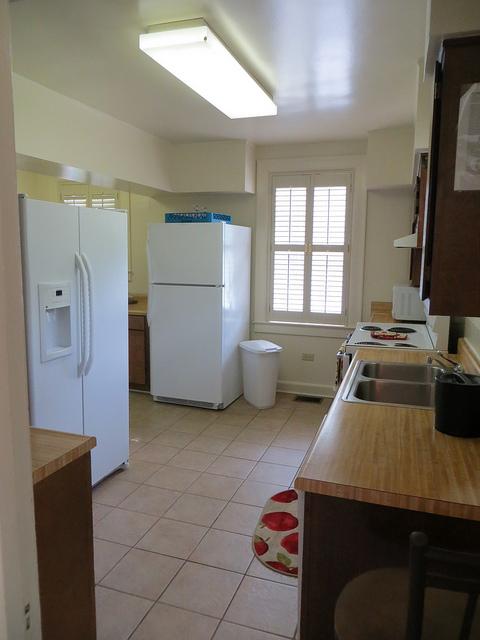Is this a large kitchen?
Answer briefly. Yes. How many windows are there?
Be succinct. 1. Is there a plant?
Concise answer only. No. What is on the refrigerator?
Quick response, please. Nothing. Can you see a clock in the picture?
Answer briefly. No. Is the room clean?
Give a very brief answer. Yes. What color is the object under the window?
Short answer required. White. What does oxidizing metal have in common with this color palette?
Give a very brief answer. Nothing. What color is the mat on the floor in front of the sink?
Keep it brief. Red and white. What color is the refrigerator?
Short answer required. White. Is there anything on the refrigerator?
Keep it brief. No. What would you use here if there was a fire?
Keep it brief. Water. Is there rugs in this room?
Short answer required. Yes. What color is the trash can?
Keep it brief. White. Are there bananas in the picture?
Be succinct. No. What color are the appliances?
Concise answer only. White. How small is this kitchen?
Give a very brief answer. Not much. How many rugs are on the floor?
Short answer required. 1. Is the outside of the refrigerator bare?
Keep it brief. Yes. Is this room neatly organized?
Answer briefly. Yes. What color is the fridge?
Answer briefly. White. Does the fridge have magnets on it?
Quick response, please. No. How many handles on the cabinets are visible?
Quick response, please. 0. What room is this?
Write a very short answer. Kitchen. What room is depicted?
Be succinct. Kitchen. Is there a picture on the side of the refrigerator?
Quick response, please. No. Is there a washing machine in this kitchen?
Keep it brief. No. What style of tiling is on the floor?
Short answer required. Square. 